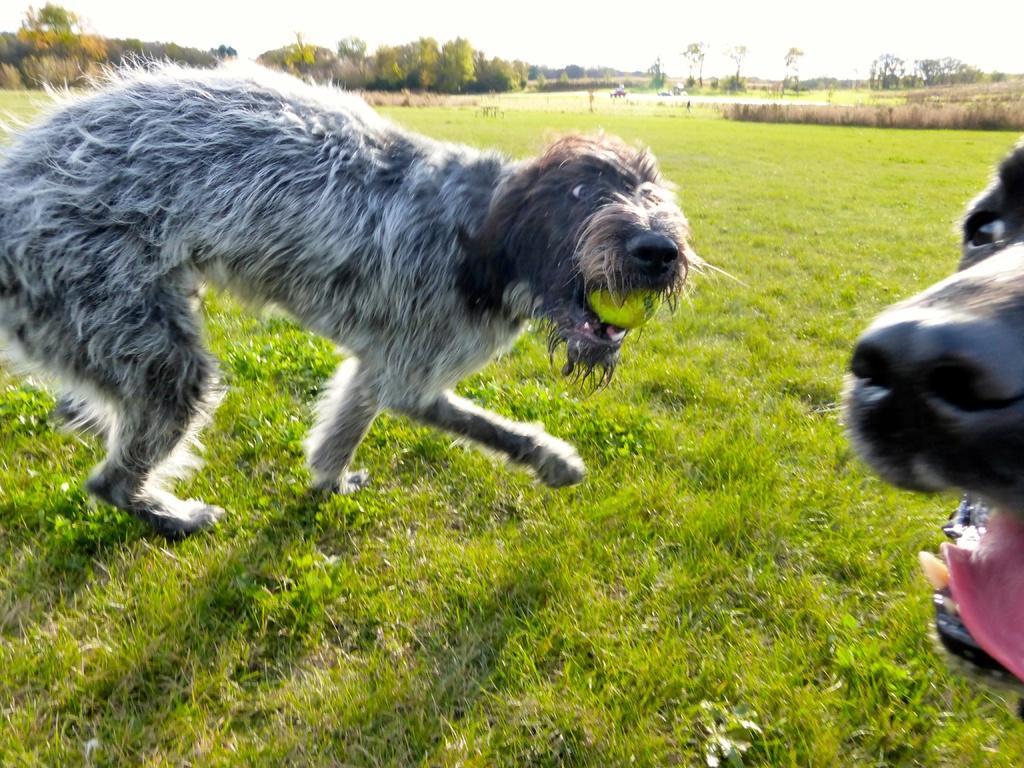Could you give a brief overview of what you see in this image? In this image we can see two dogs on the grassy land. Background of the image trees are there. 